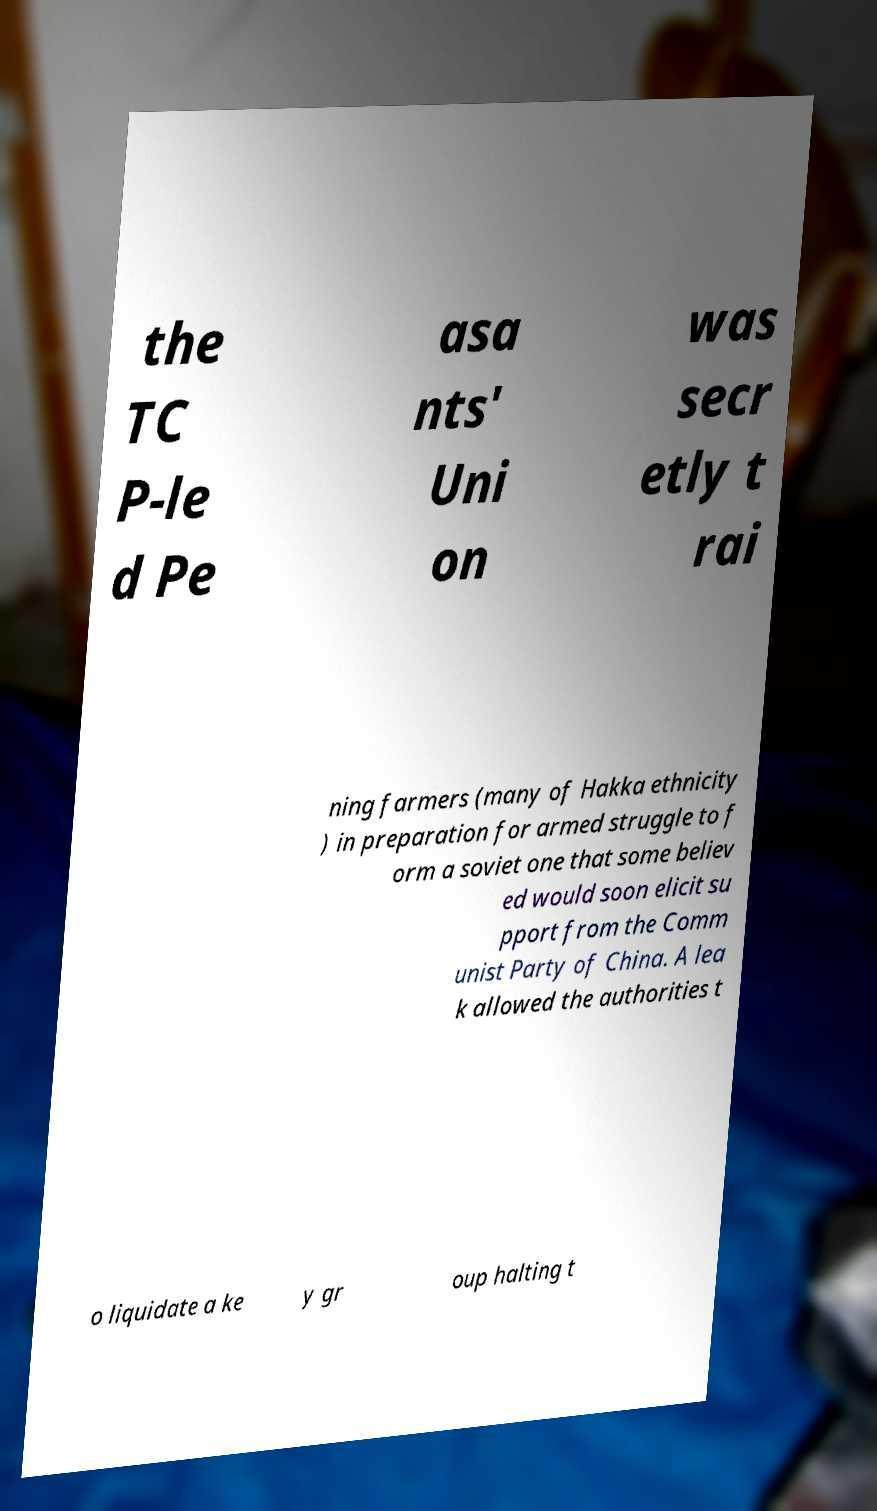There's text embedded in this image that I need extracted. Can you transcribe it verbatim? the TC P-le d Pe asa nts' Uni on was secr etly t rai ning farmers (many of Hakka ethnicity ) in preparation for armed struggle to f orm a soviet one that some believ ed would soon elicit su pport from the Comm unist Party of China. A lea k allowed the authorities t o liquidate a ke y gr oup halting t 